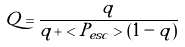<formula> <loc_0><loc_0><loc_500><loc_500>Q = \frac { q } { q + < P _ { e s c } > ( 1 - q ) }</formula> 